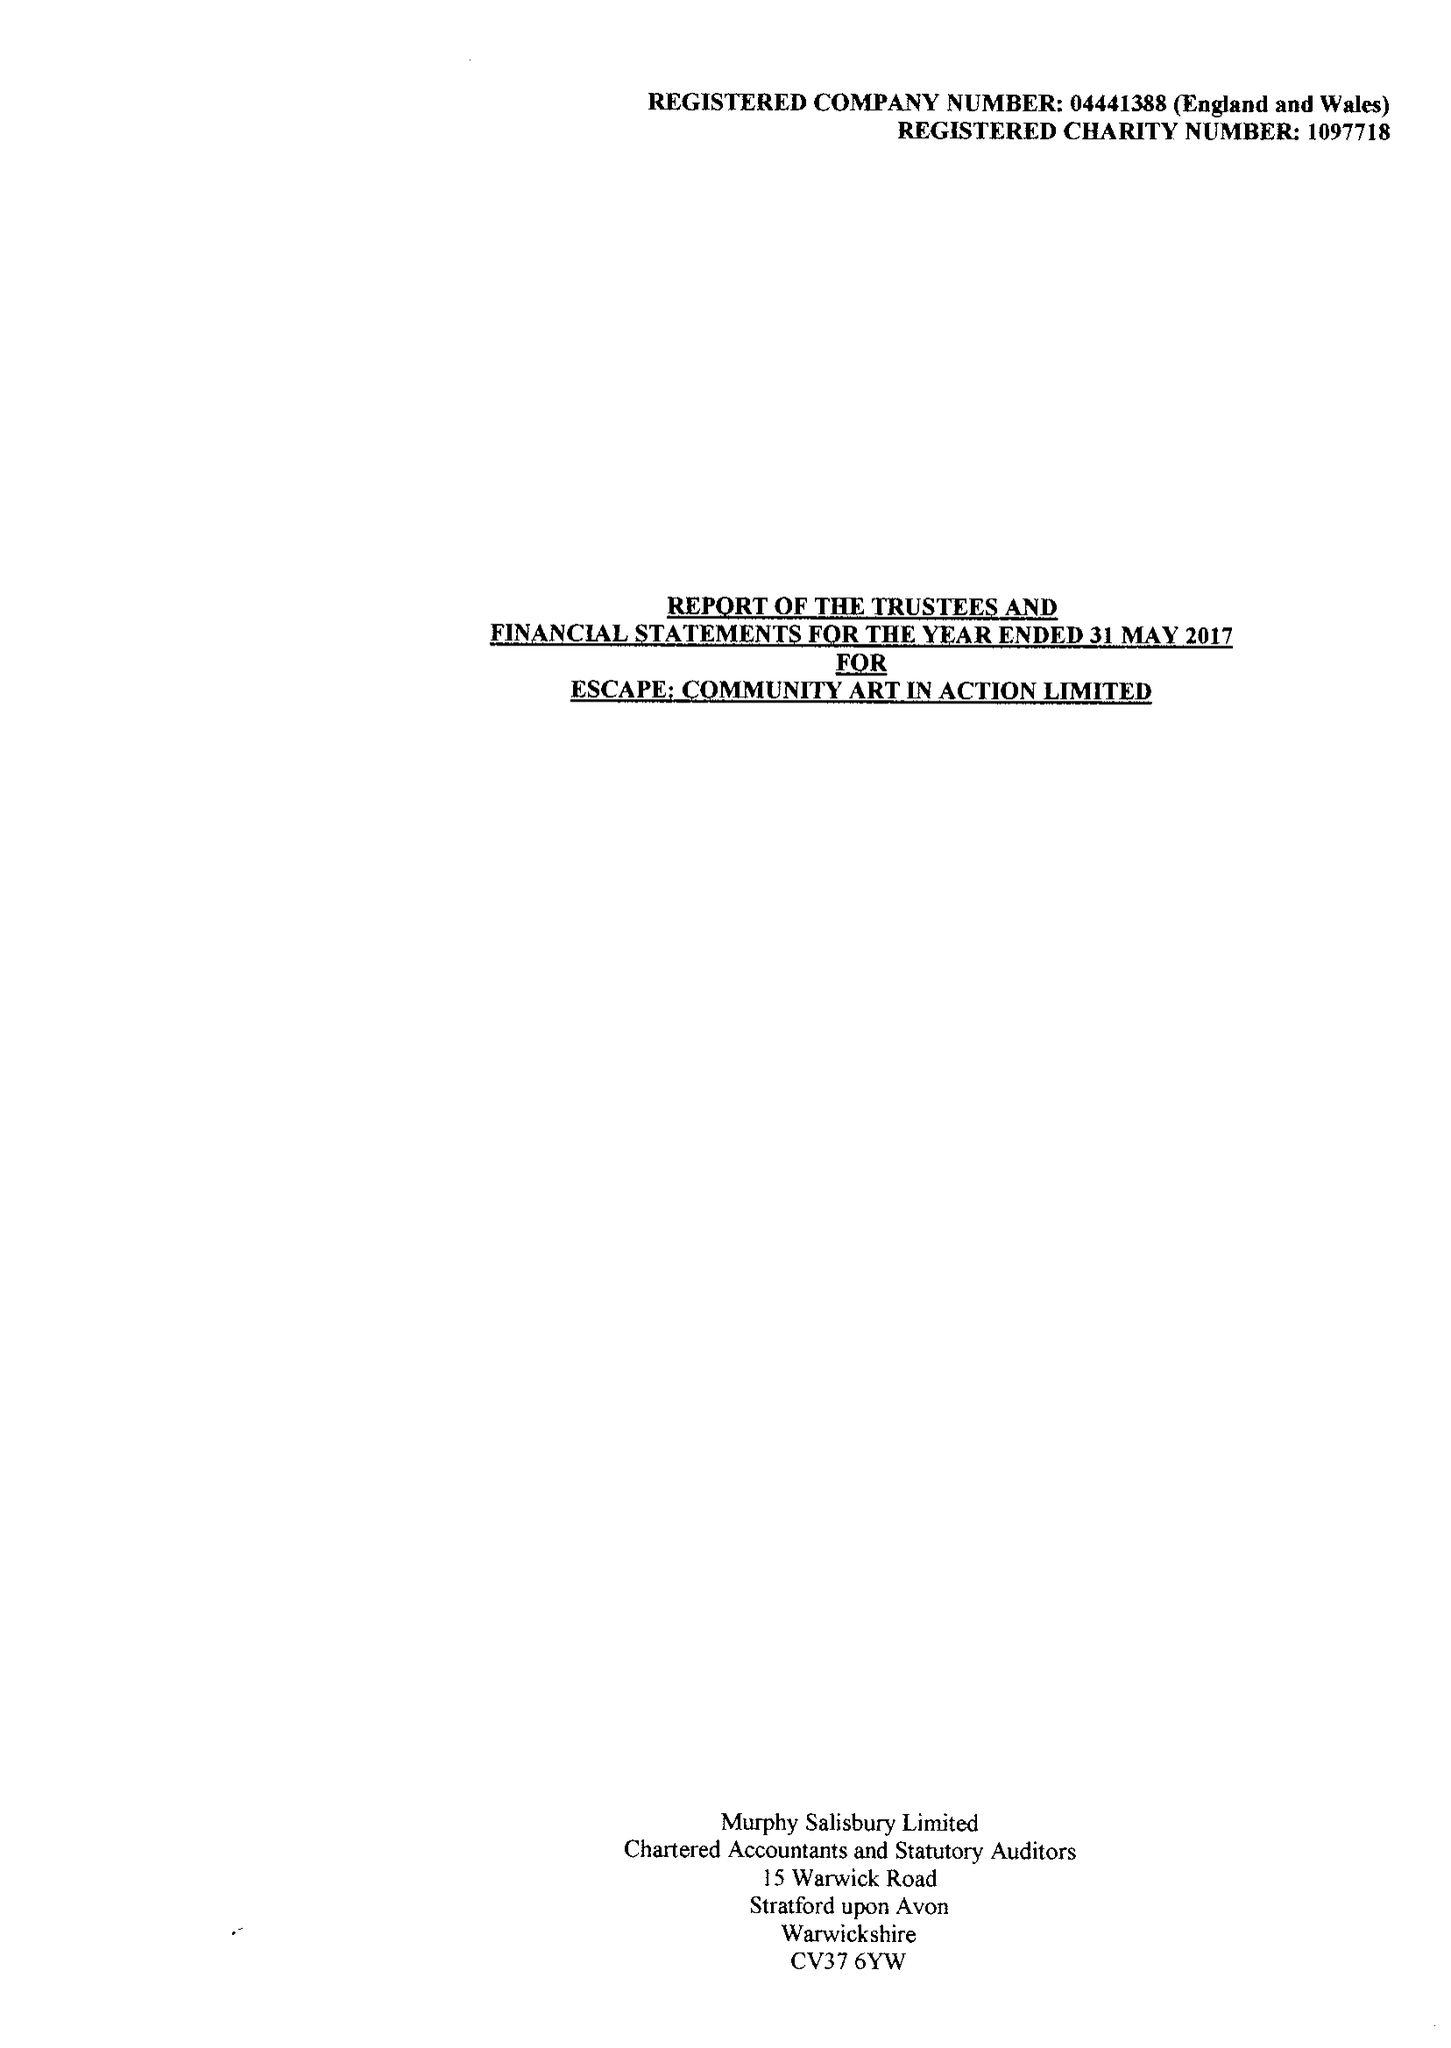What is the value for the charity_name?
Answer the question using a single word or phrase. Escape Community Art In Action 